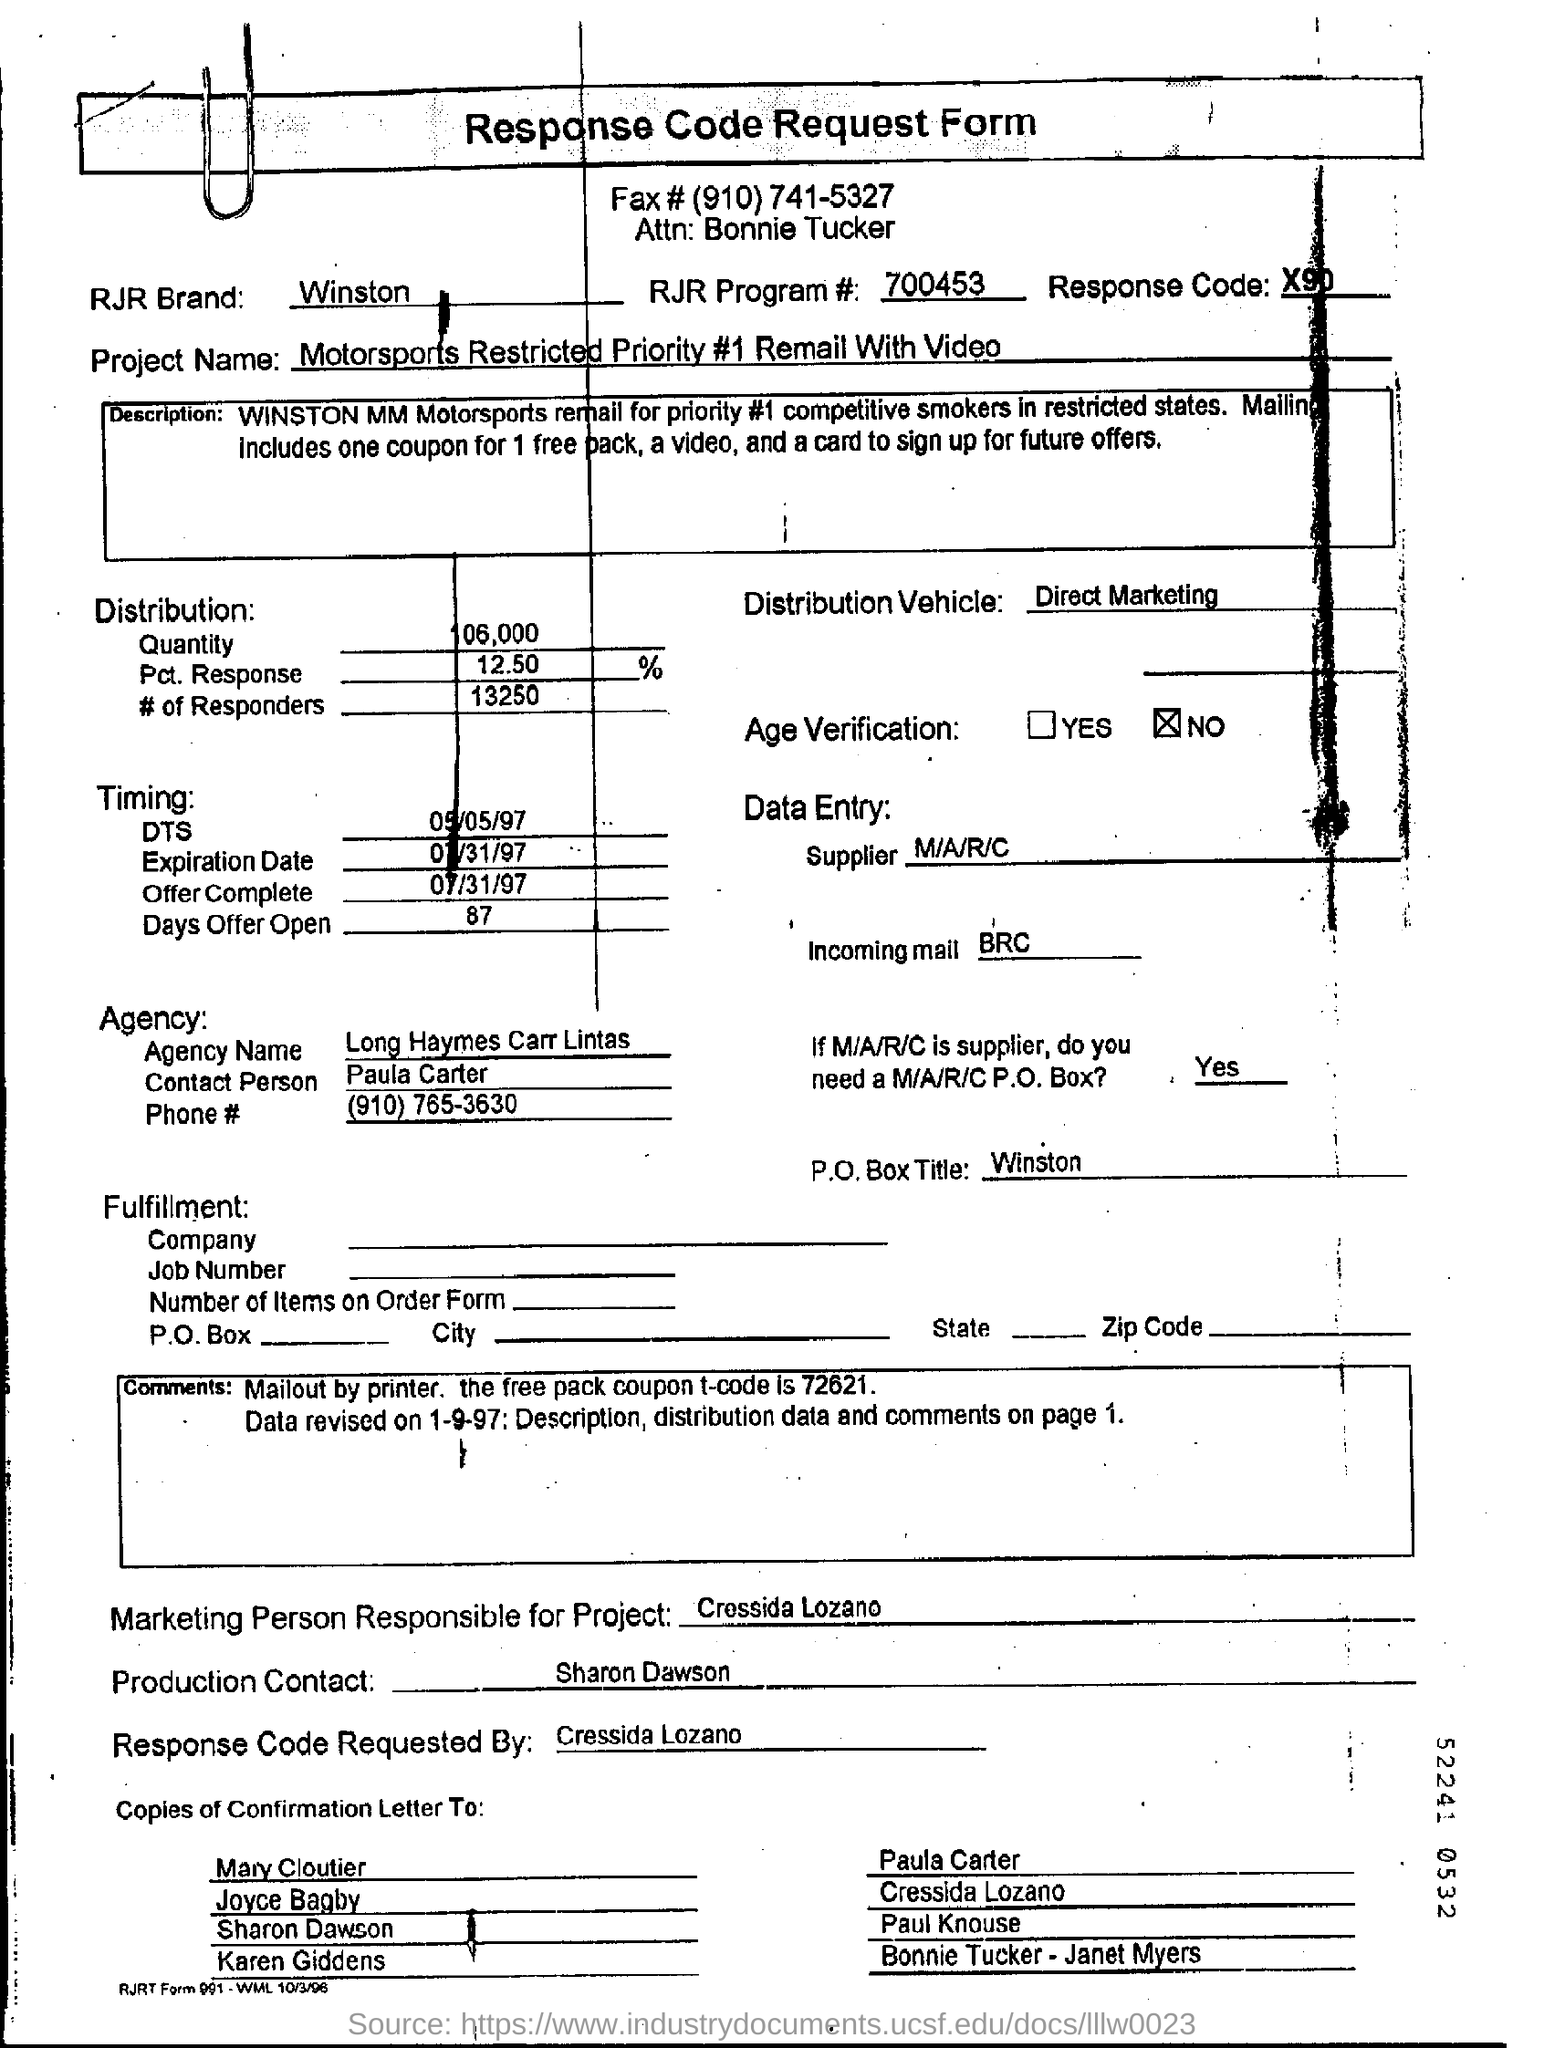What is the Fax Number ?
Your answer should be very brief. (910) 741-5327. What is written in the RJR Brand Field ?
Provide a succinct answer. Winston. What is mentioned in the Distribution Vehicle Field ?
Your answer should be compact. Direct Marketing. What is the RJR Program Number ?
Give a very brief answer. 700453. What  is mentioned in the Response Code Field ?
Make the answer very short. X90. What is written in the P.O.Box Title Field ?
Provide a succinct answer. Winston. What is the Offer Complete Date in the Document ?
Keep it short and to the point. 07/31/97. What is written in the Incoming Mail Field ?
Your answer should be compact. BRC. What is the Agency Name ?
Make the answer very short. Long Haymes Carr Lintas. 